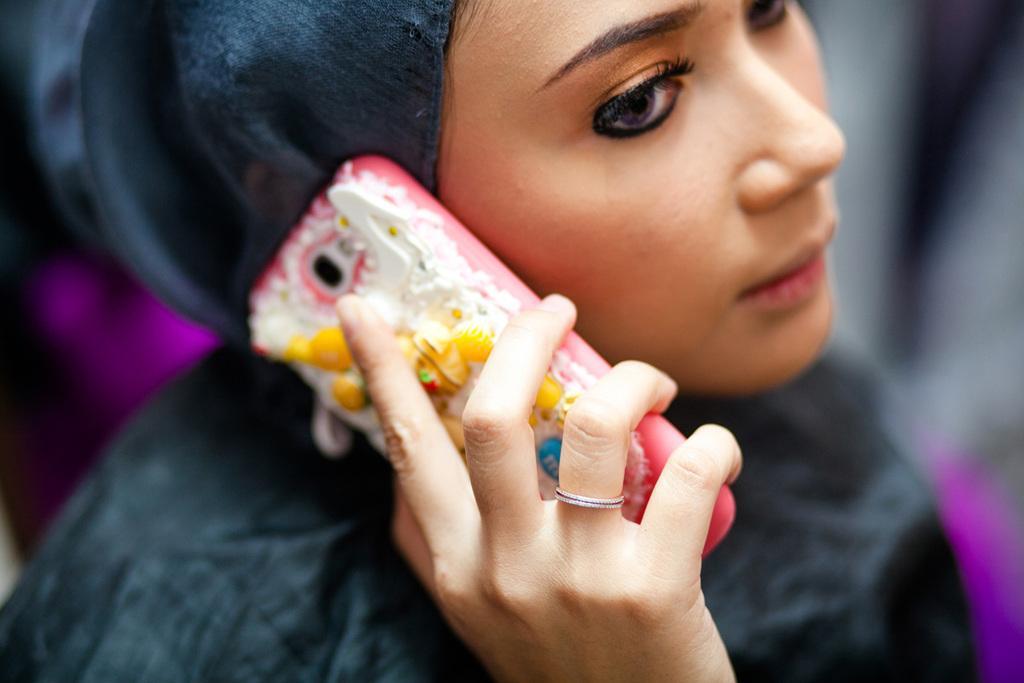Can you describe this image briefly? In this image there is a girl who is holding the mobile phone near to her ear. She is wearing the black color dress. 